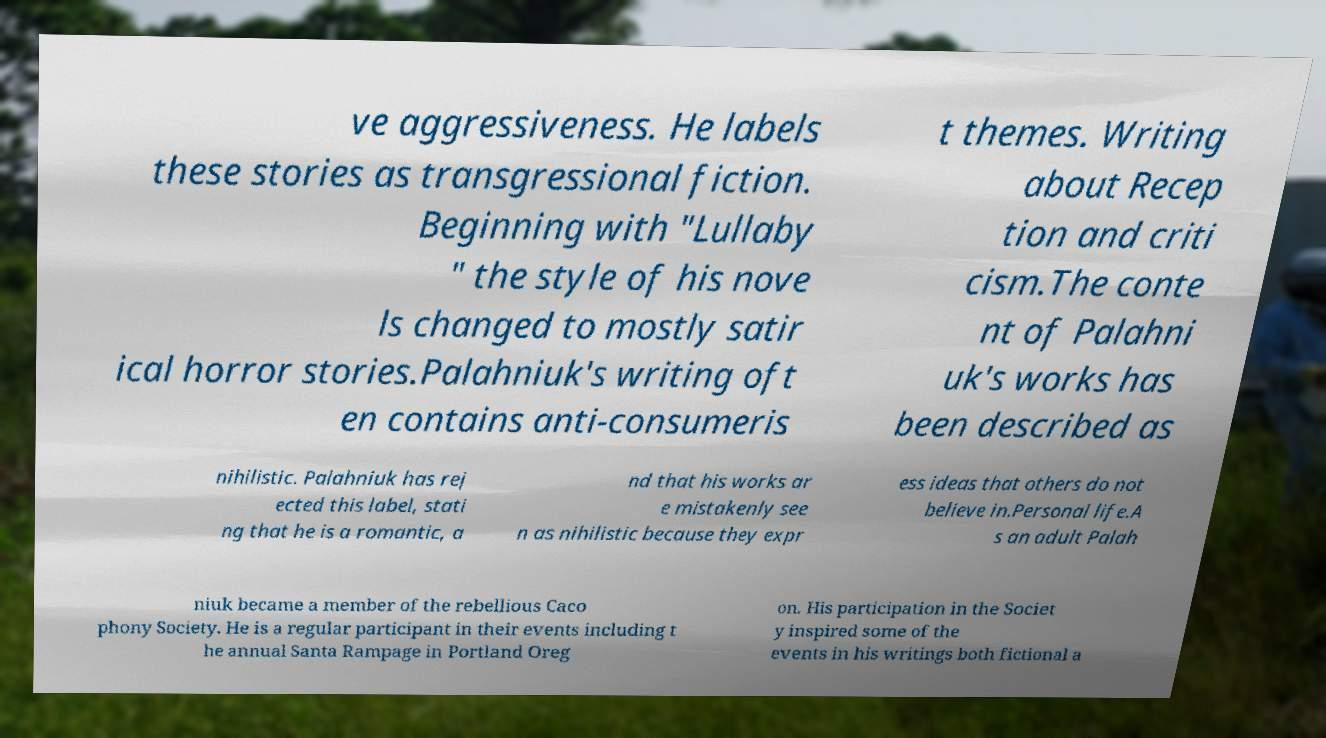Could you extract and type out the text from this image? ve aggressiveness. He labels these stories as transgressional fiction. Beginning with "Lullaby " the style of his nove ls changed to mostly satir ical horror stories.Palahniuk's writing oft en contains anti-consumeris t themes. Writing about Recep tion and criti cism.The conte nt of Palahni uk's works has been described as nihilistic. Palahniuk has rej ected this label, stati ng that he is a romantic, a nd that his works ar e mistakenly see n as nihilistic because they expr ess ideas that others do not believe in.Personal life.A s an adult Palah niuk became a member of the rebellious Caco phony Society. He is a regular participant in their events including t he annual Santa Rampage in Portland Oreg on. His participation in the Societ y inspired some of the events in his writings both fictional a 